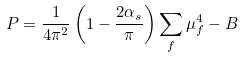<formula> <loc_0><loc_0><loc_500><loc_500>P = \frac { 1 } { 4 \pi ^ { 2 } } \left ( 1 - \frac { 2 \alpha _ { s } } { \pi } \right ) \sum _ { f } \mu _ { f } ^ { 4 } - B</formula> 